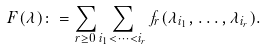Convert formula to latex. <formula><loc_0><loc_0><loc_500><loc_500>F ( \lambda ) \colon = \sum _ { r \geq 0 } \sum _ { i _ { 1 } < \dots < i _ { r } } f _ { r } ( \lambda _ { i _ { 1 } } , \dots , \lambda _ { i _ { r } } ) .</formula> 